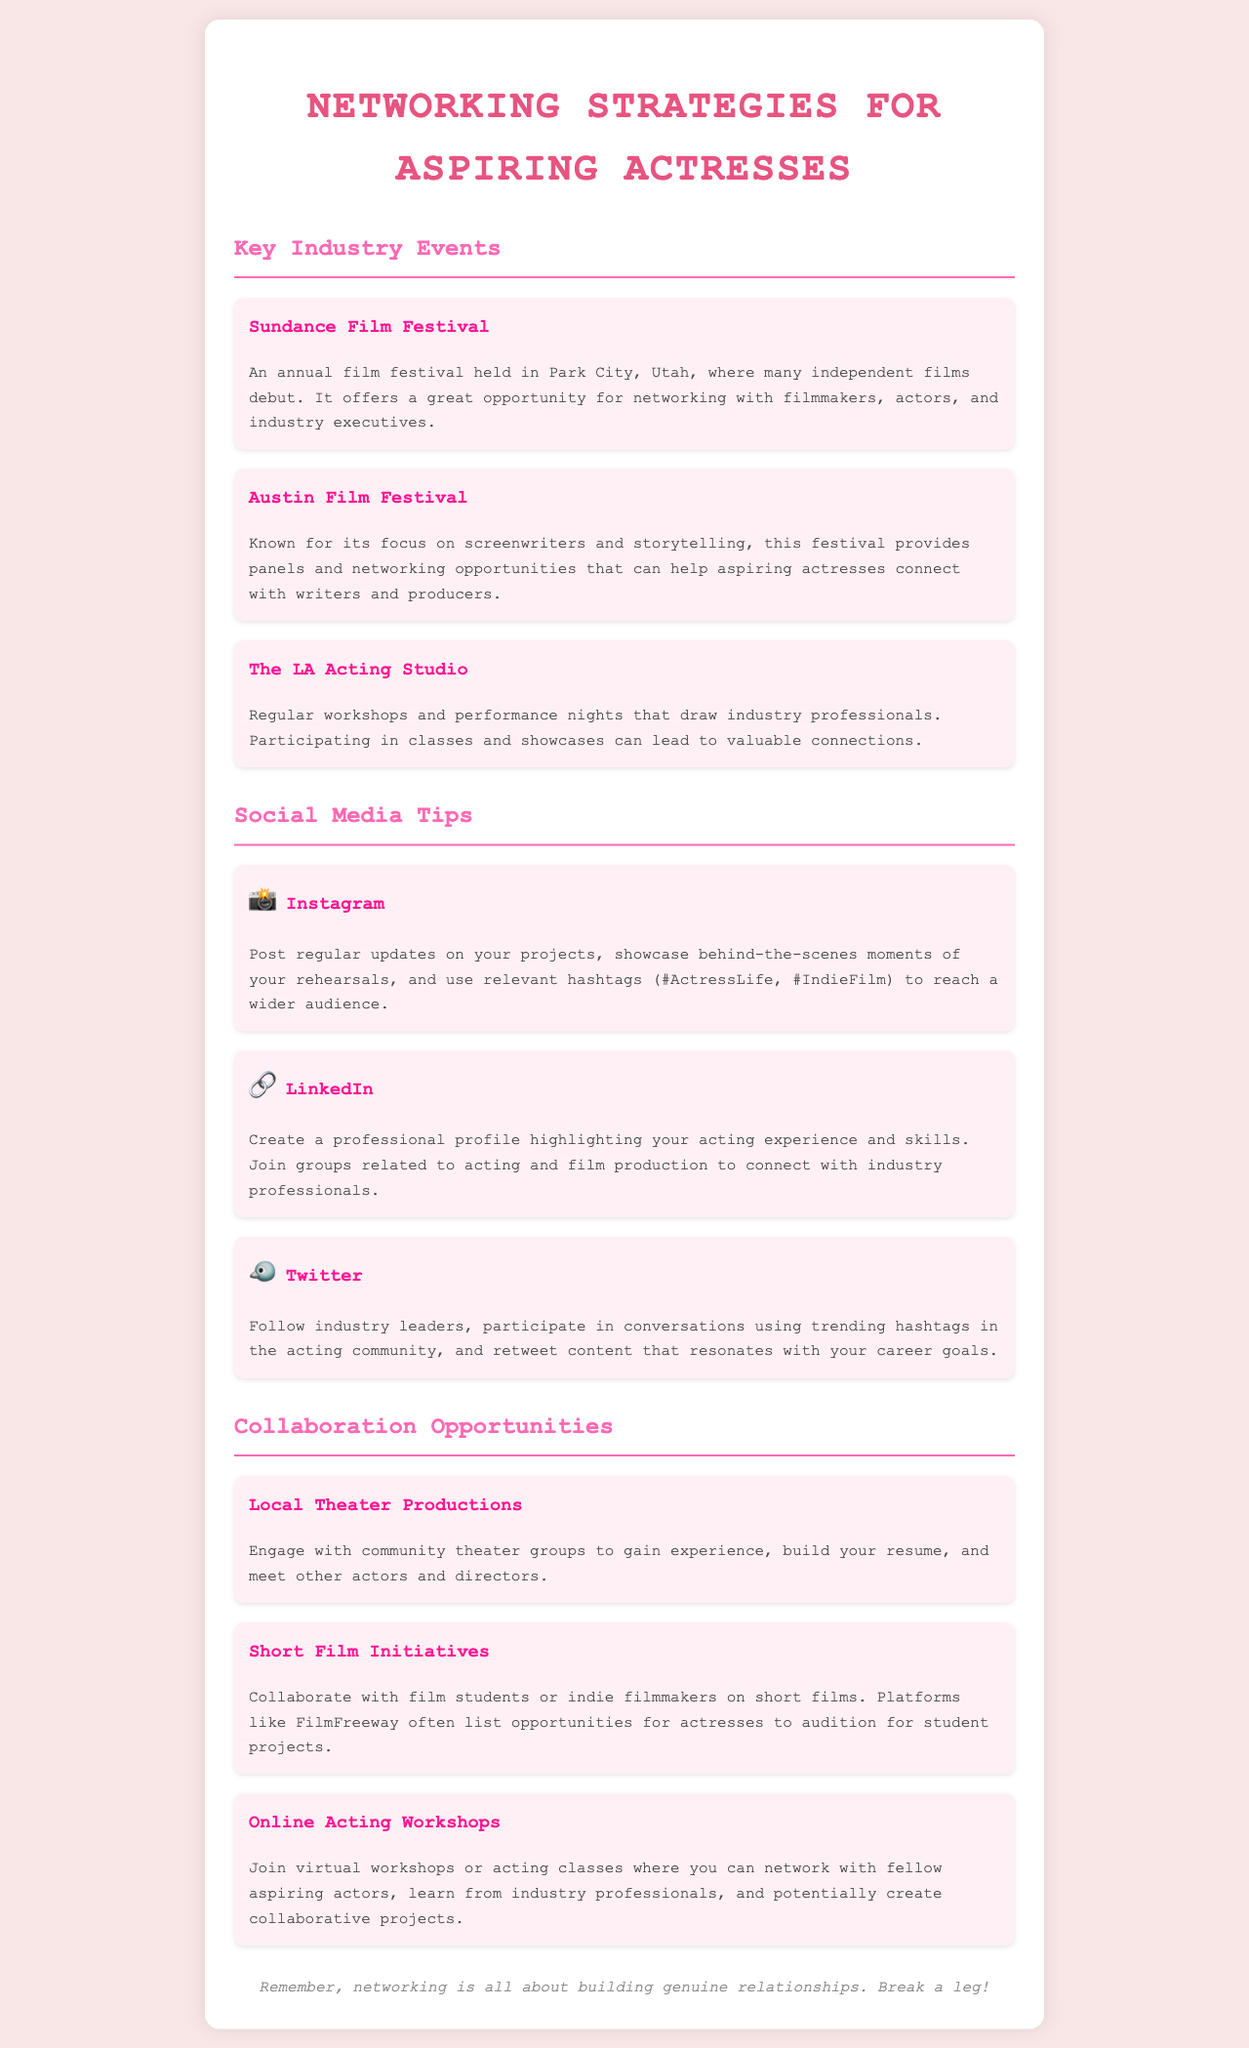What is the title of the document? The title is found in the `<title>` tag of the document, indicating the main topic it covers.
Answer: Networking Strategies for Aspiring Actresses How many key industry events are listed? The total number of key industry events is counted from the individual sections provided in the document.
Answer: Three What is one of the social media platforms mentioned for networking? This information can be retrieved from the section dedicated to social media tips, naming specific platforms.
Answer: Instagram What is the main focus of the Austin Film Festival? The document outlines the specific themes and audiences catered to by each event listed.
Answer: Screenwriters and storytelling What type of collaboration opportunity involves community groups? This refers to the specific opportunities for aspiring actresses mentioned in the collaboration section.
Answer: Local Theater Productions What is a suggested platform for audition opportunities in short films? The document provides a source for finding short film opportunities, indicating where one can look for auditions.
Answer: FilmFreeway How do you suggest following influential figures in the acting community? This is addressed in the social media tips section that discusses engagement with industry leaders.
Answer: Twitter What is the color scheme for the headings in the document? The colors used for headings can be identified through the specified style rules for each section of the document.
Answer: Pink 